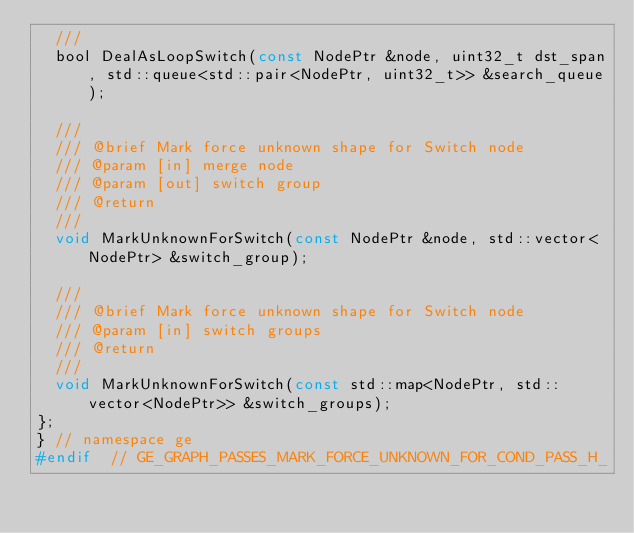<code> <loc_0><loc_0><loc_500><loc_500><_C_>  ///
  bool DealAsLoopSwitch(const NodePtr &node, uint32_t dst_span, std::queue<std::pair<NodePtr, uint32_t>> &search_queue);

  ///
  /// @brief Mark force unknown shape for Switch node
  /// @param [in] merge node
  /// @param [out] switch group
  /// @return
  ///
  void MarkUnknownForSwitch(const NodePtr &node, std::vector<NodePtr> &switch_group);

  ///
  /// @brief Mark force unknown shape for Switch node
  /// @param [in] switch groups
  /// @return
  ///
  void MarkUnknownForSwitch(const std::map<NodePtr, std::vector<NodePtr>> &switch_groups);
};
} // namespace ge
#endif  // GE_GRAPH_PASSES_MARK_FORCE_UNKNOWN_FOR_COND_PASS_H_
</code> 